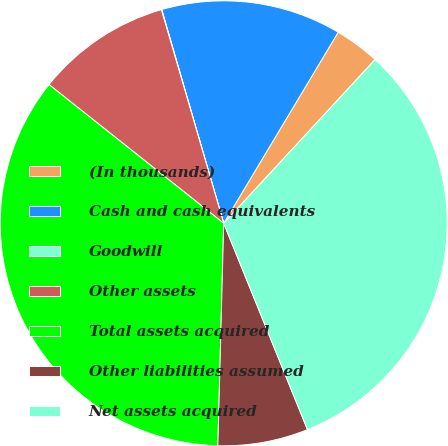Convert chart. <chart><loc_0><loc_0><loc_500><loc_500><pie_chart><fcel>(In thousands)<fcel>Cash and cash equivalents<fcel>Goodwill<fcel>Other assets<fcel>Total assets acquired<fcel>Other liabilities assumed<fcel>Net assets acquired<nl><fcel>3.28%<fcel>13.03%<fcel>0.03%<fcel>9.78%<fcel>35.3%<fcel>6.53%<fcel>32.05%<nl></chart> 